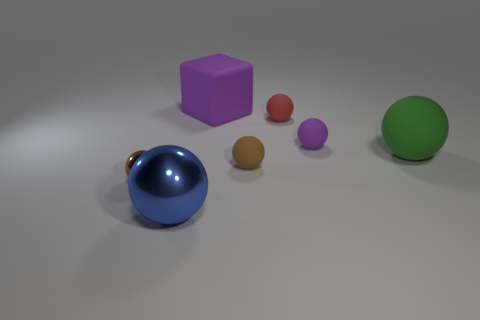How many large green objects are made of the same material as the purple cube?
Give a very brief answer. 1. Are there fewer cubes than purple things?
Make the answer very short. Yes. There is a tiny matte sphere to the left of the red matte ball; does it have the same color as the tiny metallic object?
Your answer should be very brief. Yes. How many tiny matte objects are left of the large ball to the left of the big thing on the right side of the small red rubber object?
Offer a very short reply. 0. There is a big rubber sphere; what number of purple objects are in front of it?
Keep it short and to the point. 0. The small metallic object that is the same shape as the big green object is what color?
Provide a short and direct response. Brown. The big thing that is both on the left side of the red rubber thing and behind the big shiny ball is made of what material?
Provide a succinct answer. Rubber. There is a brown object that is to the right of the blue metal object; does it have the same size as the purple matte sphere?
Provide a succinct answer. Yes. What is the material of the large blue sphere?
Ensure brevity in your answer.  Metal. There is a rubber thing that is in front of the big green matte ball; what is its color?
Make the answer very short. Brown. 